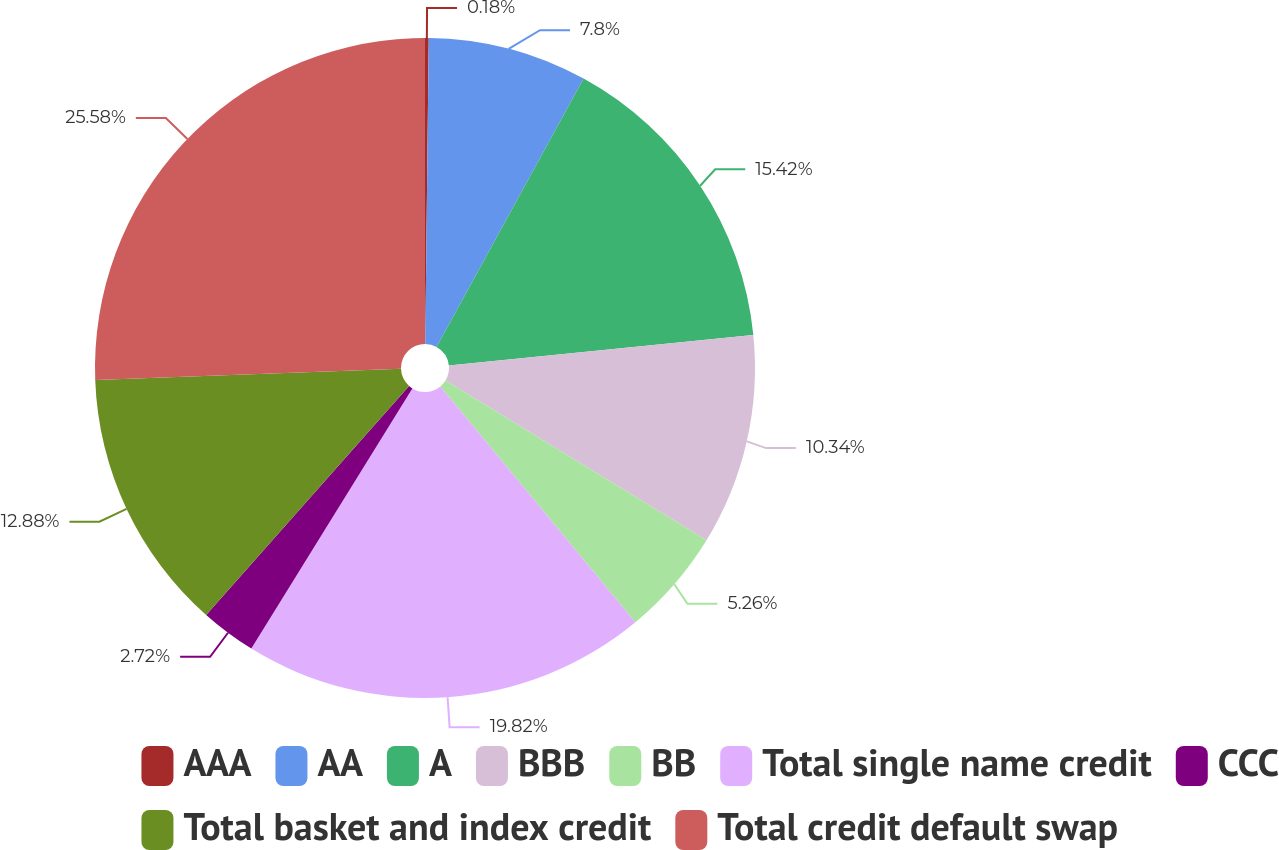<chart> <loc_0><loc_0><loc_500><loc_500><pie_chart><fcel>AAA<fcel>AA<fcel>A<fcel>BBB<fcel>BB<fcel>Total single name credit<fcel>CCC<fcel>Total basket and index credit<fcel>Total credit default swap<nl><fcel>0.18%<fcel>7.8%<fcel>15.42%<fcel>10.34%<fcel>5.26%<fcel>19.82%<fcel>2.72%<fcel>12.88%<fcel>25.58%<nl></chart> 